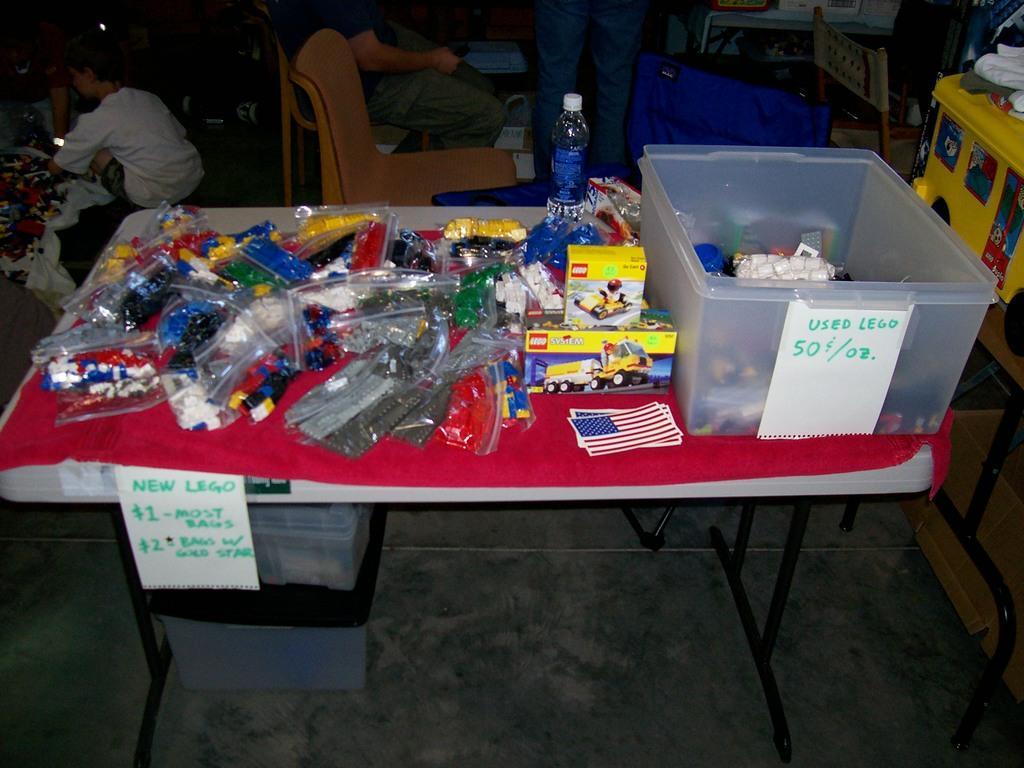Can you describe this image briefly? In this picture we can see a table. On the table there are packets, boxes, and a bottle. Here we can see a man who is sitting on the chair. And this is floor. 